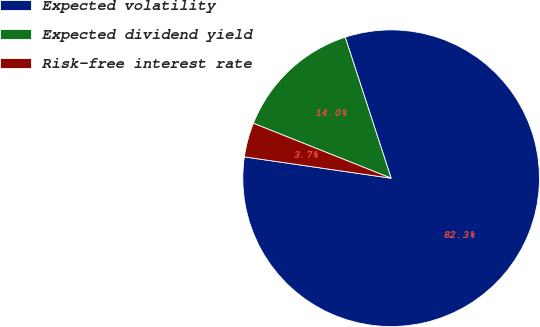Convert chart to OTSL. <chart><loc_0><loc_0><loc_500><loc_500><pie_chart><fcel>Expected volatility<fcel>Expected dividend yield<fcel>Risk-free interest rate<nl><fcel>82.31%<fcel>13.95%<fcel>3.74%<nl></chart> 